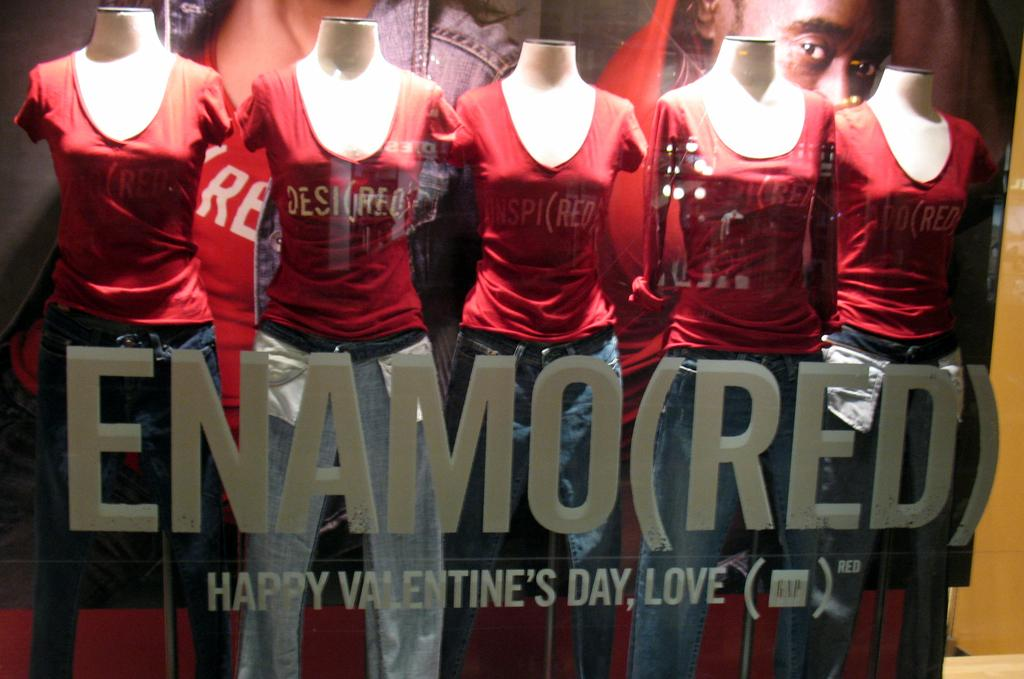<image>
Give a short and clear explanation of the subsequent image. A storefront has a happy Valentine's day message on it below the name. 